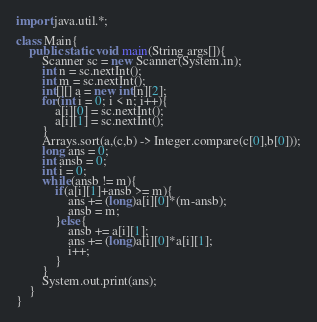<code> <loc_0><loc_0><loc_500><loc_500><_Java_>import java.util.*;

class Main{
	public static void main(String args[]){
		Scanner sc = new Scanner(System.in);
		int n = sc.nextInt();
		int m = sc.nextInt();
		int[][] a = new int[n][2];
		for(int i = 0; i < n; i++){
			a[i][0] = sc.nextInt();
			a[i][1] = sc.nextInt();
		}
		Arrays.sort(a,(c,b) -> Integer.compare(c[0],b[0]));
		long ans = 0;
		int ansb = 0;
		int i = 0;
		while(ansb != m){
			if(a[i][1]+ansb >= m){
				ans += (long)a[i][0]*(m-ansb);
				ansb = m;
			}else{
				ansb += a[i][1];
				ans += (long)a[i][0]*a[i][1];
				i++;
			}
		}
		System.out.print(ans);
	}
}
</code> 